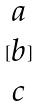Convert formula to latex. <formula><loc_0><loc_0><loc_500><loc_500>[ \begin{matrix} a \\ b \\ c \end{matrix} ]</formula> 